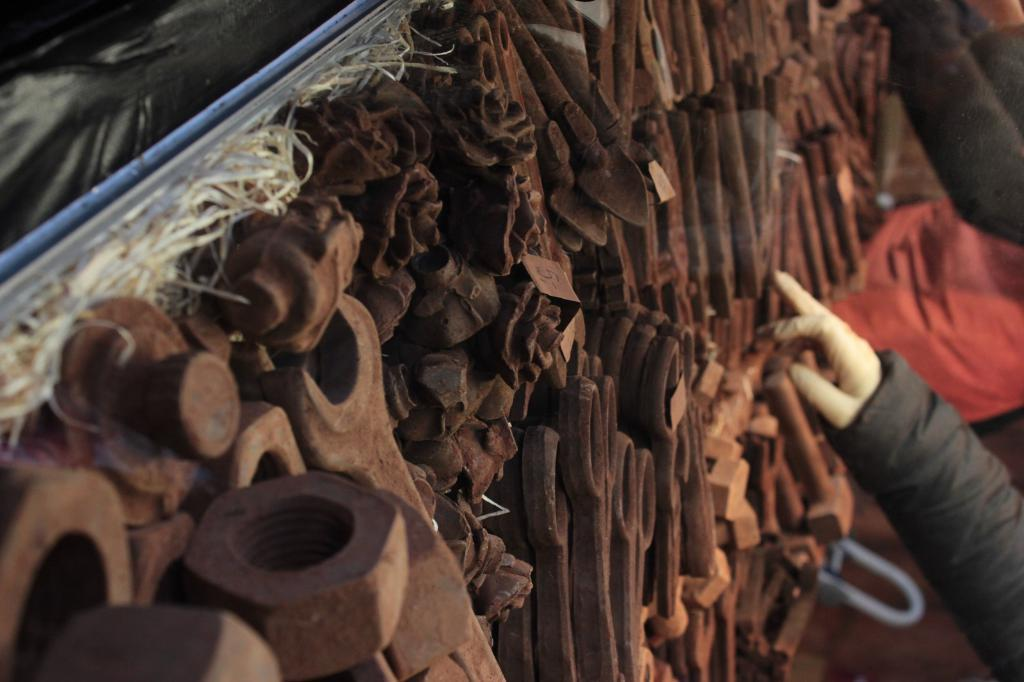What type of objects are located in the middle of the image? There are iron objects in the middle of the image. Can you describe anything else visible in the image? A human hand is visible on the right side of the image. What type of wax can be smelled coming from the iron objects in the image? There is no wax or scent mentioned in the image, and therefore it cannot be determined if any scent is present. 